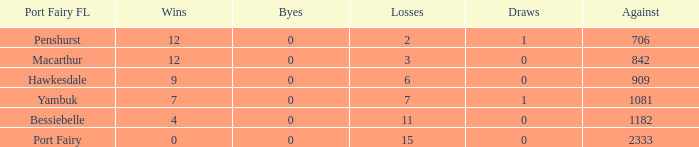I'm looking to parse the entire table for insights. Could you assist me with that? {'header': ['Port Fairy FL', 'Wins', 'Byes', 'Losses', 'Draws', 'Against'], 'rows': [['Penshurst', '12', '0', '2', '1', '706'], ['Macarthur', '12', '0', '3', '0', '842'], ['Hawkesdale', '9', '0', '6', '0', '909'], ['Yambuk', '7', '0', '7', '1', '1081'], ['Bessiebelle', '4', '0', '11', '0', '1182'], ['Port Fairy', '0', '0', '15', '0', '2333']]} How many draws are there in the port fairy fl when hawkesdale has over 9 victories? None. 